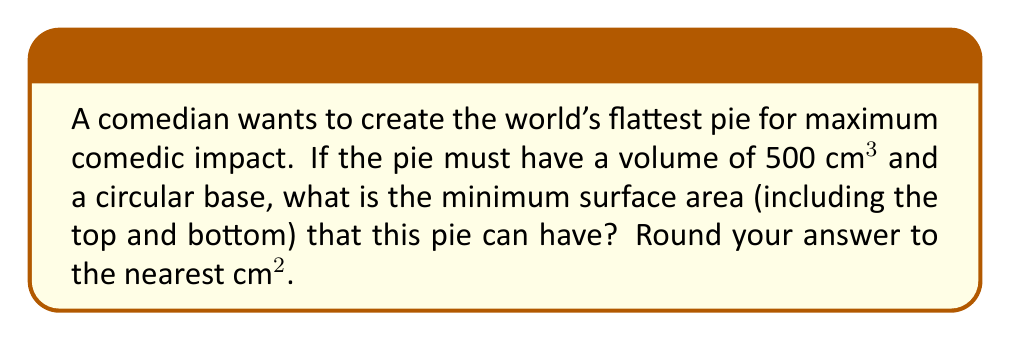Can you answer this question? Let's approach this step-by-step:

1) Let $r$ be the radius of the circular base and $h$ be the height of the pie.

2) The volume of a cylinder is given by $V = \pi r^2 h$. We're told the volume is 500 cm³, so:

   $$500 = \pi r^2 h$$

3) The surface area of a cylinder (including top and bottom) is given by:
   
   $$S = 2\pi r^2 + 2\pi rh$$

4) We want to minimize S. We can express h in terms of r using the volume equation:

   $$h = \frac{500}{\pi r^2}$$

5) Substituting this into the surface area equation:

   $$S = 2\pi r^2 + 2\pi r(\frac{500}{\pi r^2}) = 2\pi r^2 + \frac{1000}{r}$$

6) To find the minimum, we differentiate S with respect to r and set it to zero:

   $$\frac{dS}{dr} = 4\pi r - \frac{1000}{r^2} = 0$$

7) Solving this equation:

   $$4\pi r^3 = 1000$$
   $$r^3 = \frac{250}{\pi}$$
   $$r = \sqrt[3]{\frac{250}{\pi}} \approx 3.95 \text{ cm}$$

8) We can verify this is a minimum by checking the second derivative is positive.

9) Now we can calculate h:

   $$h = \frac{500}{\pi r^2} \approx 10.17 \text{ cm}$$

10) Finally, we can calculate the minimum surface area:

    $$S = 2\pi r^2 + 2\pi rh \approx 351.86 \text{ cm}²$$

11) Rounding to the nearest cm², we get 352 cm².
Answer: 352 cm² 